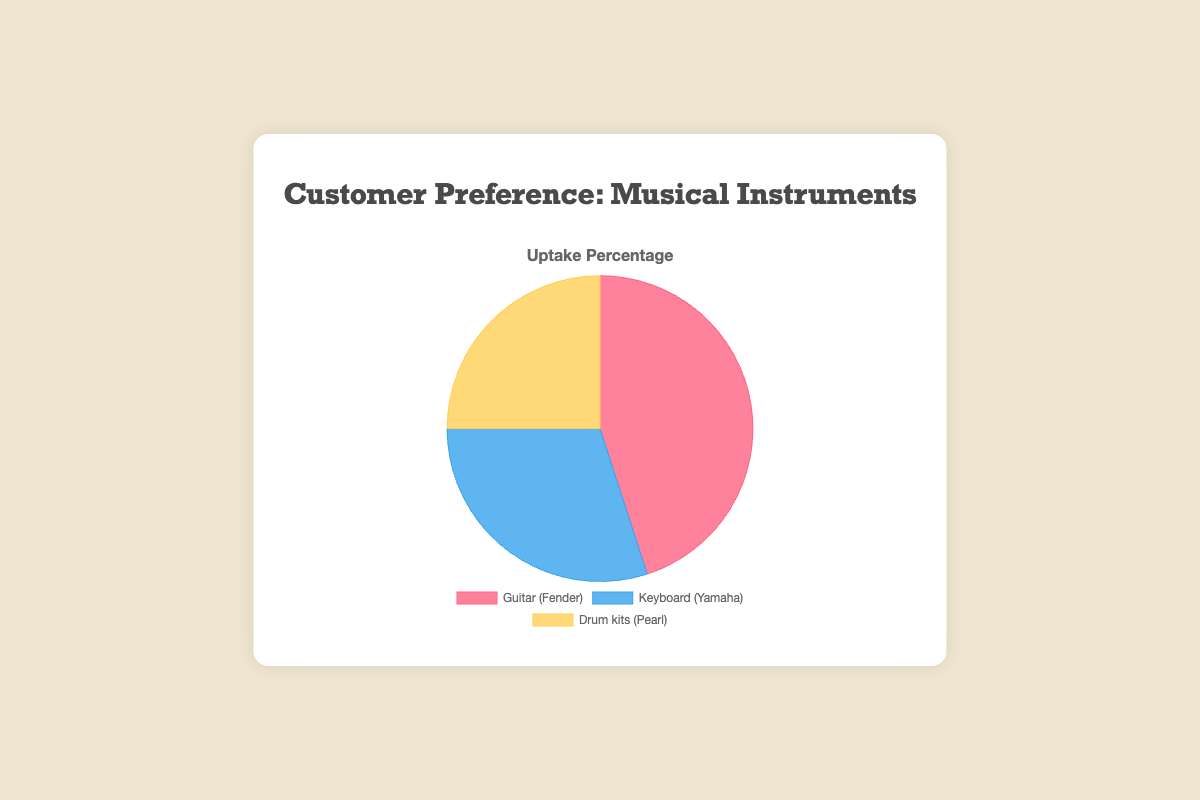What percentage of customers prefer the Guitar (Fender)? The pie chart shows the uptake of different musical instruments as percentages. By looking at the section labeled 'Guitar (Fender)', we can see that it constitutes 45% of the chart.
Answer: 45% Which musical instrument has the lowest uptake percentage? By observing the segments of the pie chart and their corresponding percentages, the Drum kits (Pearl) have the smallest segment with 25%.
Answer: Drum kits (Pearl) How much higher is the uptake percentage for Guitars (Fender) than Drum kits (Pearl)? First, note the uptake percentages for Guitars (Fender) and Drum kits (Pearl), which are 45% and 25% respectively. Subtract the percentage of Drum kits (Pearl) from that of Guitars (Fender): 45% - 25% = 20%.
Answer: 20% What is the total percentage of customers who prefer either Keyboards (Yamaha) or Drum kits (Pearl)? Identify the uptake percentages for both Keyboards (Yamaha) and Drum kits (Pearl): 30% and 25%, respectively. Add these two percentages together: 30% + 25% = 55%.
Answer: 55% What fraction of the chart is dedicated to Keyboards (Yamaha) in comparison to the whole pie? The uptake percentage for Keyboards (Yamaha) is 30%. Since the whole chart represents 100%, the fraction for Keyboards (Yamaha) is 30/100, which simplifies to 3/10.
Answer: 3/10 Which product category's segment is shaded blue in the chart? The Keyboards (Yamaha) segment is labeled and shaded in blue in the pie chart.
Answer: Keyboards (Yamaha) Is the uptake percentage for Keyboards higher or lower than the combined percentage for Guitars and Drum kits? First, find the combined percentage for Guitars (Fender) and Drum kits (Pearl): 45% + 25% = 70%. Then compare this to the Keyboards (Yamaha) percentage, which is 30%. Since 30% is less than 70%, the uptake for Keyboards is lower.
Answer: Lower What's the percentage difference between the highest and the lowest preference categories? Identify the highest uptake percentage (Guitars at 45%) and the lowest uptake percentage (Drum kits at 25%). Subtract the lowest percentage from the highest: 45% - 25% = 20%.
Answer: 20% If the percentage for each category is doubled, what will be the new percentage for each? Doubling each percentage: Guitars: 45% * 2 = 90%, Keyboards: 30% * 2 = 60%, Drum kits: 25% * 2 = 50%. Note that these values exceed 100%, but this is for calculation purposes.
Answer: Guitars: 90%, Keyboards: 60%, Drum kits: 50% 